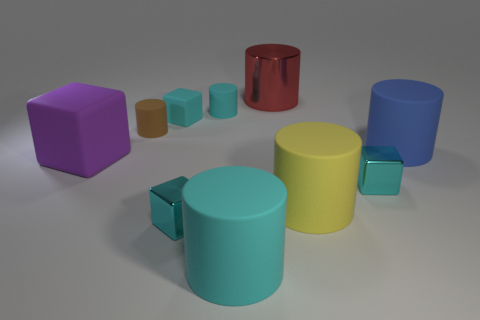How many cyan cubes must be subtracted to get 1 cyan cubes? 2 Subtract all brown cylinders. How many cyan cubes are left? 3 Subtract all tiny cyan cylinders. How many cylinders are left? 5 Subtract all yellow cylinders. How many cylinders are left? 5 Subtract 1 cylinders. How many cylinders are left? 5 Subtract all yellow cylinders. Subtract all blue spheres. How many cylinders are left? 5 Subtract all cylinders. How many objects are left? 4 Subtract 0 gray cylinders. How many objects are left? 10 Subtract all purple rubber objects. Subtract all large red metallic cylinders. How many objects are left? 8 Add 8 red metal cylinders. How many red metal cylinders are left? 9 